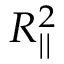Convert formula to latex. <formula><loc_0><loc_0><loc_500><loc_500>R _ { | | } ^ { 2 }</formula> 